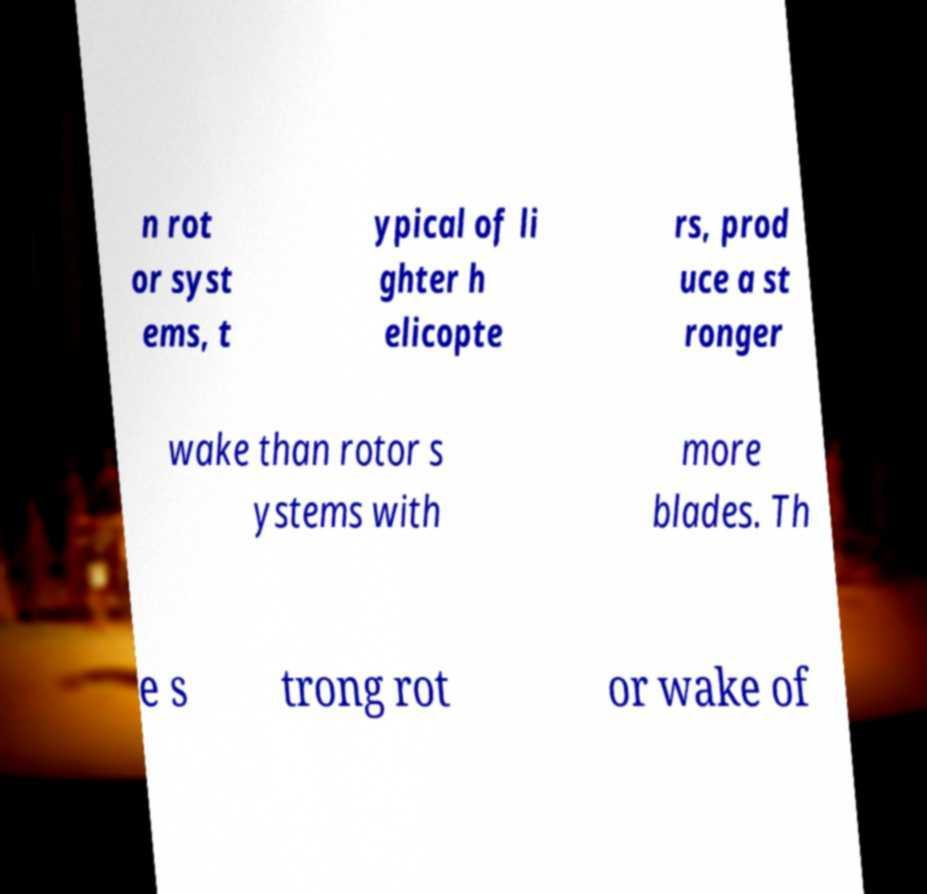Can you read and provide the text displayed in the image?This photo seems to have some interesting text. Can you extract and type it out for me? n rot or syst ems, t ypical of li ghter h elicopte rs, prod uce a st ronger wake than rotor s ystems with more blades. Th e s trong rot or wake of 